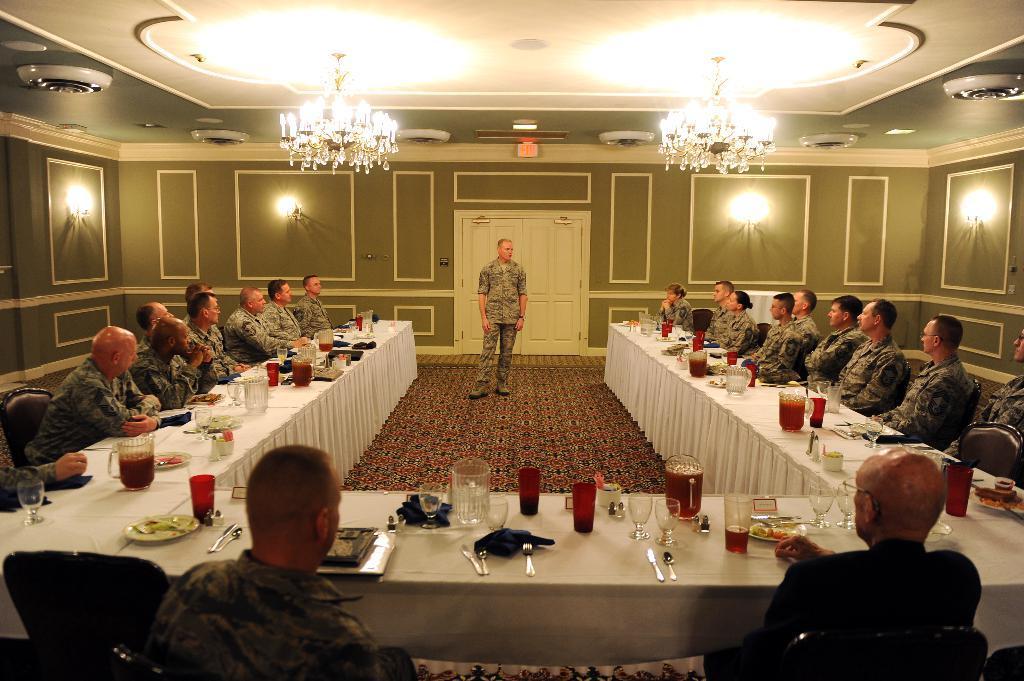Can you describe this image briefly? In this image I can see the group of people sitting in-front of the table and one person is standing. On the table there are glasses,spoons and the plates. There are lights and the door in this room. 